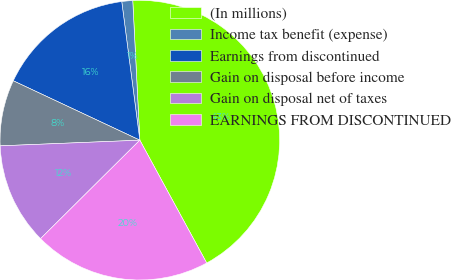<chart> <loc_0><loc_0><loc_500><loc_500><pie_chart><fcel>(In millions)<fcel>Income tax benefit (expense)<fcel>Earnings from discontinued<fcel>Gain on disposal before income<fcel>Gain on disposal net of taxes<fcel>EARNINGS FROM DISCONTINUED<nl><fcel>42.87%<fcel>1.26%<fcel>15.95%<fcel>7.63%<fcel>11.79%<fcel>20.5%<nl></chart> 